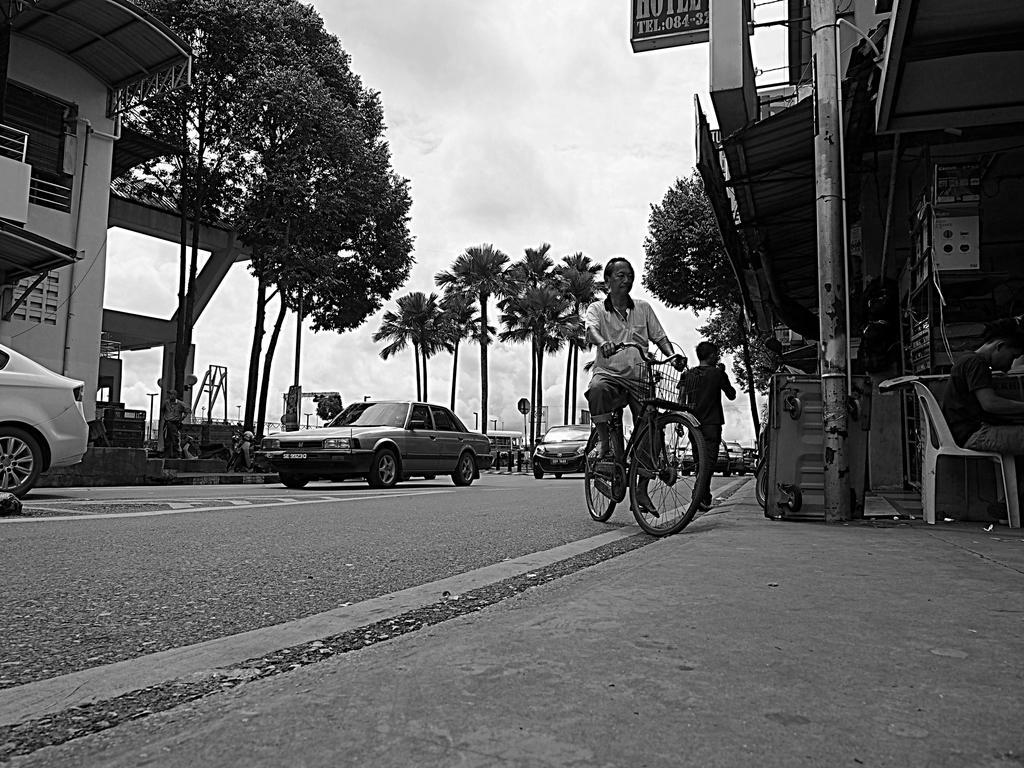Describe this image in one or two sentences. There is a road on which some vehicles are moving. Some of them are cars. There is a man on the bicycle. We can observe a bowl here and chair on which some boy is sitting. There are some trees and in the background we can observe clouds. 